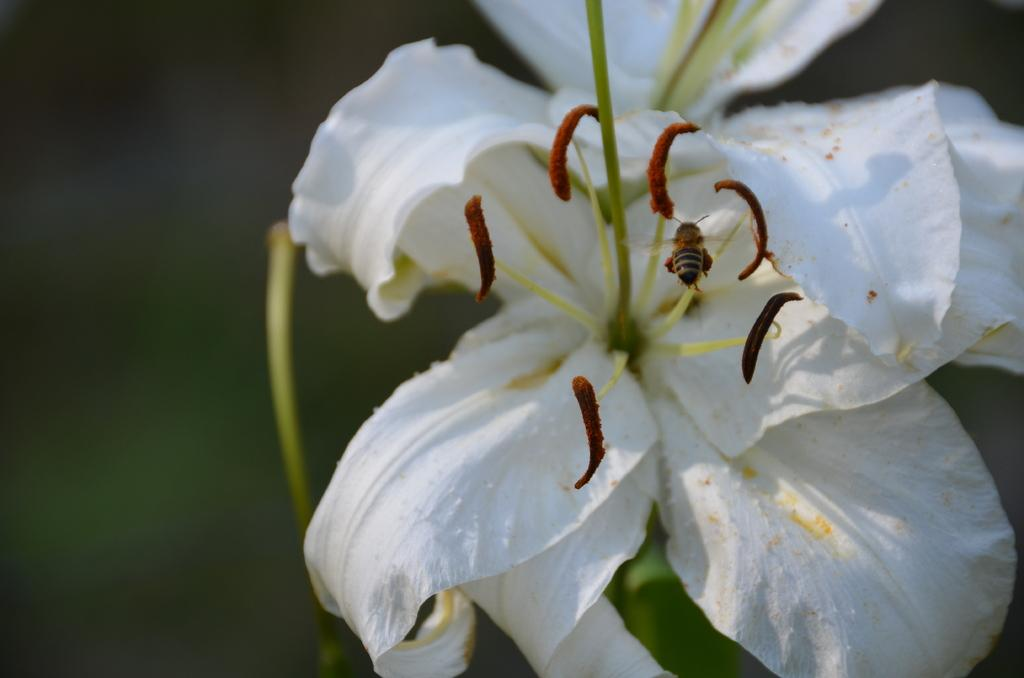What type of flowers are present in the image? There are two white color flowers on the right side of the image. Can you describe any other living organisms in the image? Yes, there is an insect on one of the flowers. What is the appearance of the background in the image? The background of the image is blurred. What type of money can be seen in the image? There is no money present in the image. What season is depicted in the image? The provided facts do not mention any seasonal elements, so it cannot be determined from the image. 